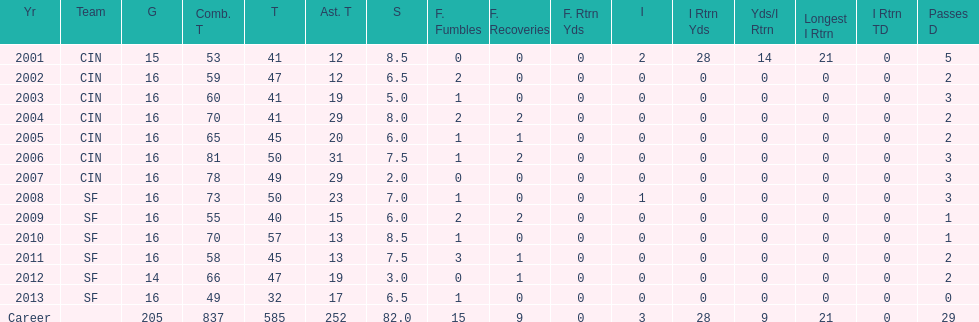What was the number of combined tackles in 2010? 70. 